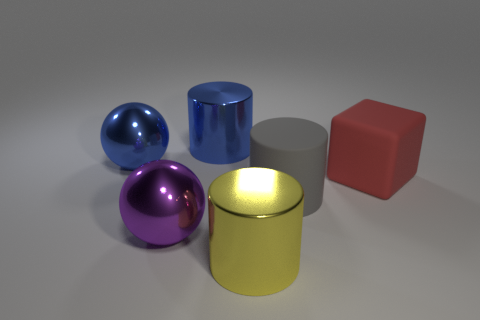What is the color of the object that is right of the large purple thing and behind the big red object?
Your answer should be compact. Blue. What number of purple spheres are the same material as the blue cylinder?
Provide a succinct answer. 1. How many yellow metallic balls are there?
Your response must be concise. 0. There is a big cylinder on the right side of the metallic cylinder that is in front of the red block; what is its material?
Keep it short and to the point. Rubber. Do the purple metallic thing and the shiny thing left of the purple object have the same shape?
Your answer should be very brief. Yes. What is the gray cylinder made of?
Ensure brevity in your answer.  Rubber. How many rubber objects are gray objects or big purple things?
Provide a short and direct response. 1. Is the number of yellow things behind the gray object less than the number of big blue objects behind the matte block?
Give a very brief answer. Yes. Are there any purple metallic things that are right of the shiny sphere that is right of the metallic ball behind the big red object?
Ensure brevity in your answer.  No. There is a blue object to the left of the purple ball; is it the same shape as the large purple metal thing left of the blue metal cylinder?
Keep it short and to the point. Yes. 